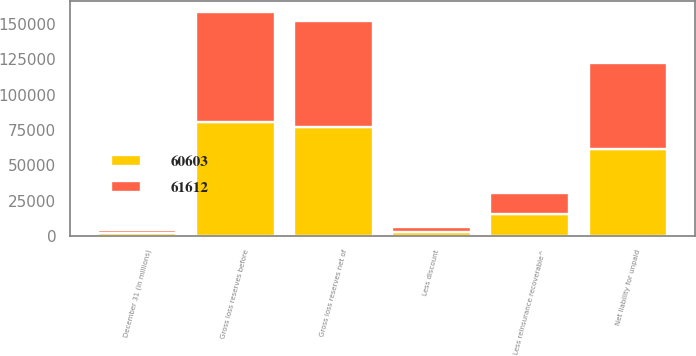<chart> <loc_0><loc_0><loc_500><loc_500><stacked_bar_chart><ecel><fcel>December 31 (in millions)<fcel>Gross loss reserves before<fcel>Less discount<fcel>Gross loss reserves net of<fcel>Less reinsurance recoverable^<fcel>Net liability for unpaid<nl><fcel>61612<fcel>2015<fcel>78090<fcel>3148<fcel>74942<fcel>14339<fcel>60603<nl><fcel>60603<fcel>2014<fcel>80337<fcel>3077<fcel>77260<fcel>15648<fcel>61612<nl></chart> 